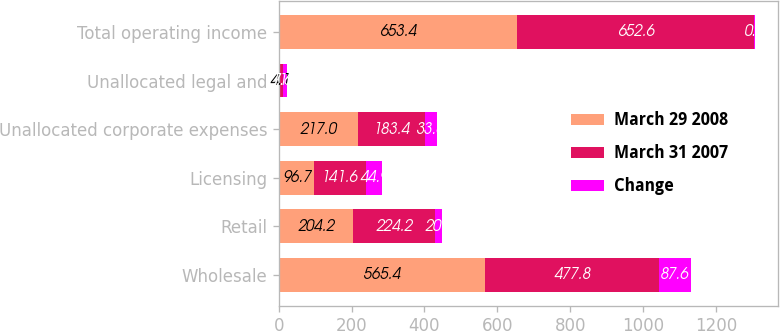<chart> <loc_0><loc_0><loc_500><loc_500><stacked_bar_chart><ecel><fcel>Wholesale<fcel>Retail<fcel>Licensing<fcel>Unallocated corporate expenses<fcel>Unallocated legal and<fcel>Total operating income<nl><fcel>March 29 2008<fcel>565.4<fcel>204.2<fcel>96.7<fcel>217<fcel>4.1<fcel>653.4<nl><fcel>March 31 2007<fcel>477.8<fcel>224.2<fcel>141.6<fcel>183.4<fcel>7.6<fcel>652.6<nl><fcel>Change<fcel>87.6<fcel>20<fcel>44.9<fcel>33.6<fcel>11.7<fcel>0.8<nl></chart> 